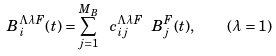Convert formula to latex. <formula><loc_0><loc_0><loc_500><loc_500>B ^ { \Lambda \lambda F } _ { i } ( t ) = \sum _ { j = 1 } ^ { M _ { B } } \ c ^ { \Lambda \lambda F } _ { i j } \ B _ { j } ^ { F } ( t ) , \quad ( \lambda = 1 )</formula> 